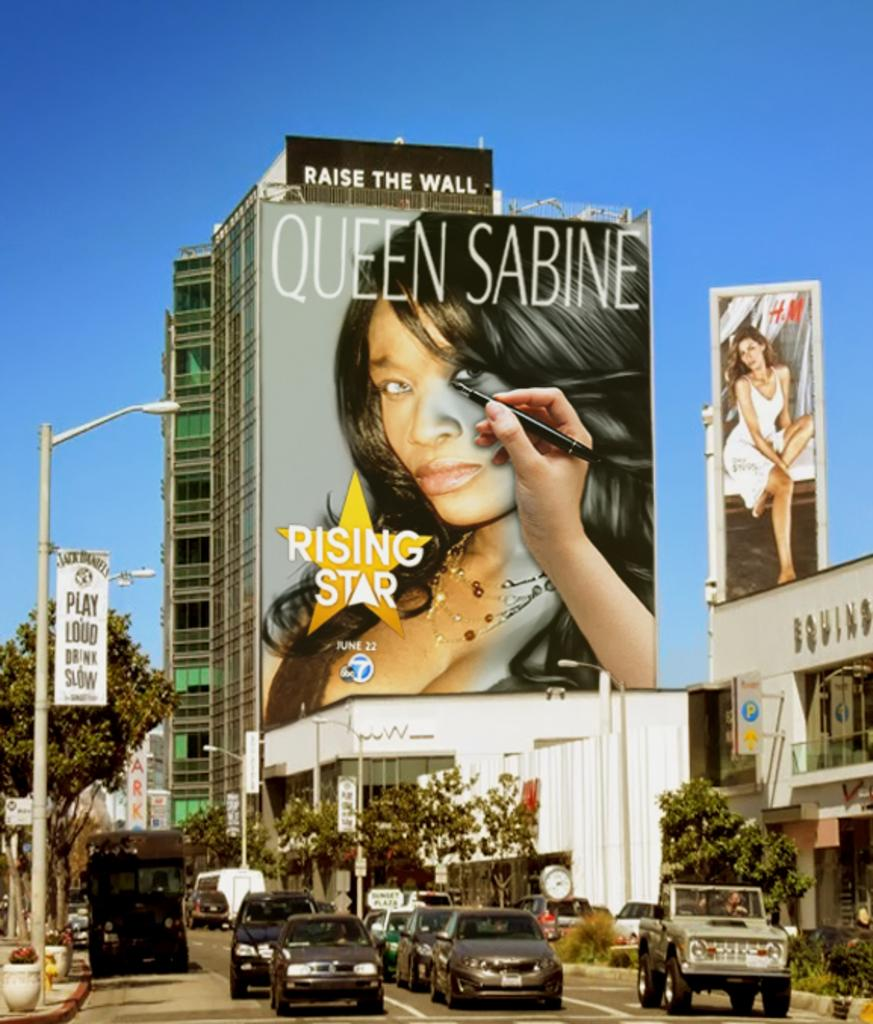<image>
Give a short and clear explanation of the subsequent image. A billboard poster of Queen Sabine a rising star. 